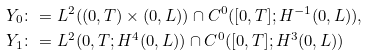<formula> <loc_0><loc_0><loc_500><loc_500>& Y _ { 0 } \colon = L ^ { 2 } ( ( 0 , T ) \times ( 0 , L ) ) \cap C ^ { 0 } ( [ 0 , T ] ; H ^ { - 1 } ( 0 , L ) ) , \\ & Y _ { 1 } \colon = L ^ { 2 } ( 0 , T ; H ^ { 4 } ( 0 , L ) ) \cap C ^ { 0 } ( [ 0 , T ] ; H ^ { 3 } ( 0 , L ) )</formula> 